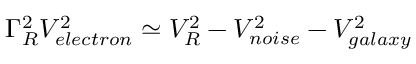<formula> <loc_0><loc_0><loc_500><loc_500>{ \Gamma _ { R } ^ { 2 } } { V _ { e l e c t r o n } ^ { 2 } } \simeq { V _ { R } ^ { 2 } } - { V _ { n o i s e } ^ { 2 } } - { V _ { g a l a x y } ^ { 2 } }</formula> 